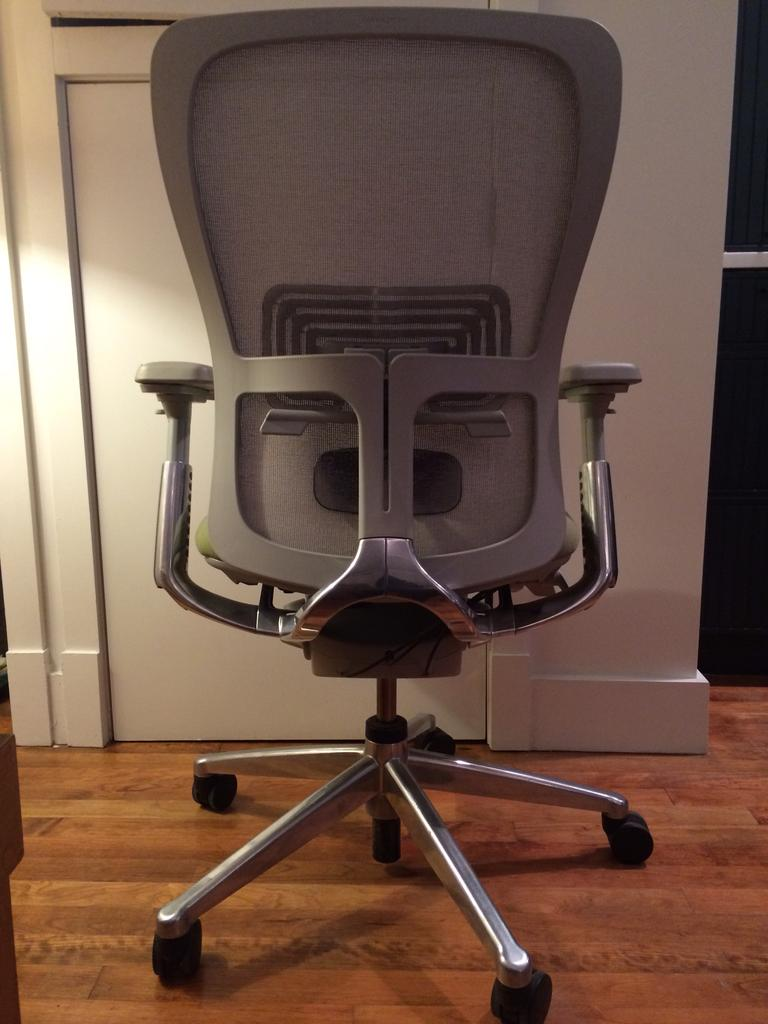What is the main object in the center of the image? There is a chair in the center of the image. What can be seen in the background of the image? There is a board in the background of the image. What type of surface is visible at the bottom of the image? There is a floor visible at the bottom of the image. What type of pickle is sitting on the chair in the image? There is no pickle present in the image; the main object is a chair. Can you describe the goat that is standing on the board in the background? There is no goat present in the image; the background features a board. 